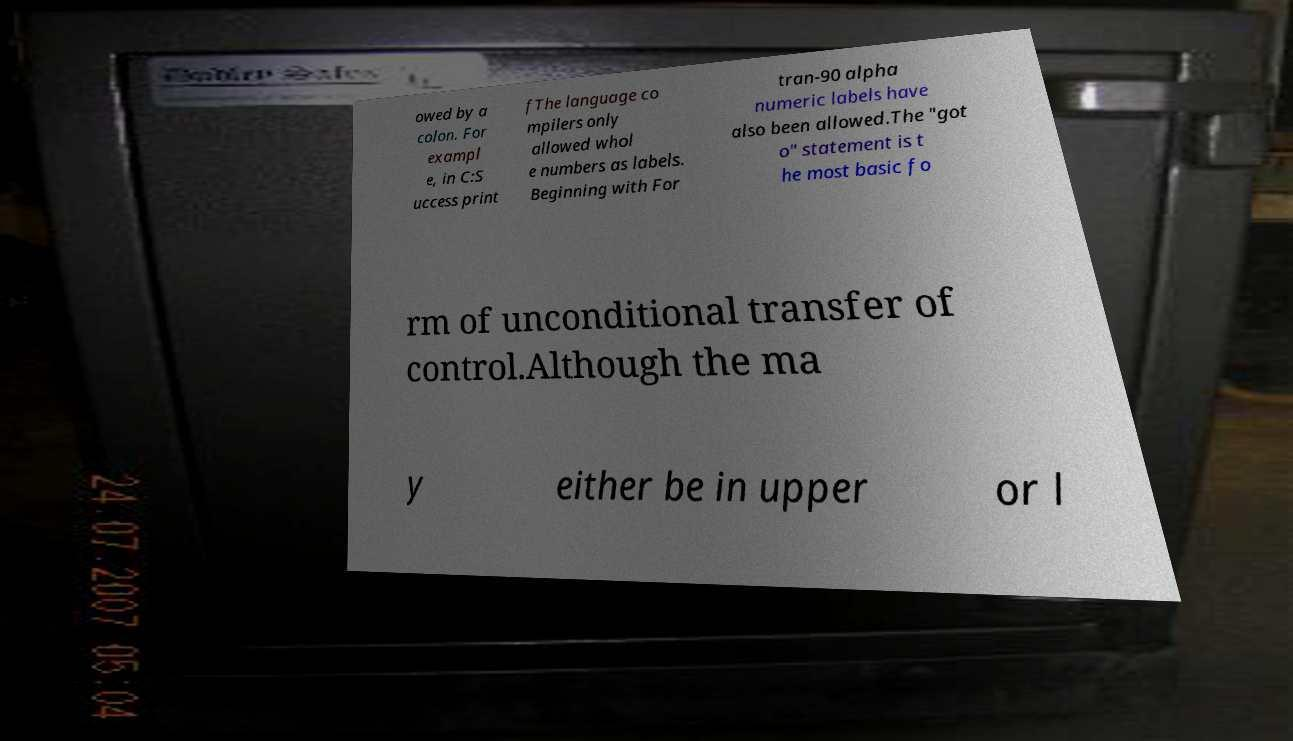Could you assist in decoding the text presented in this image and type it out clearly? owed by a colon. For exampl e, in C:S uccess print fThe language co mpilers only allowed whol e numbers as labels. Beginning with For tran-90 alpha numeric labels have also been allowed.The "got o" statement is t he most basic fo rm of unconditional transfer of control.Although the ma y either be in upper or l 